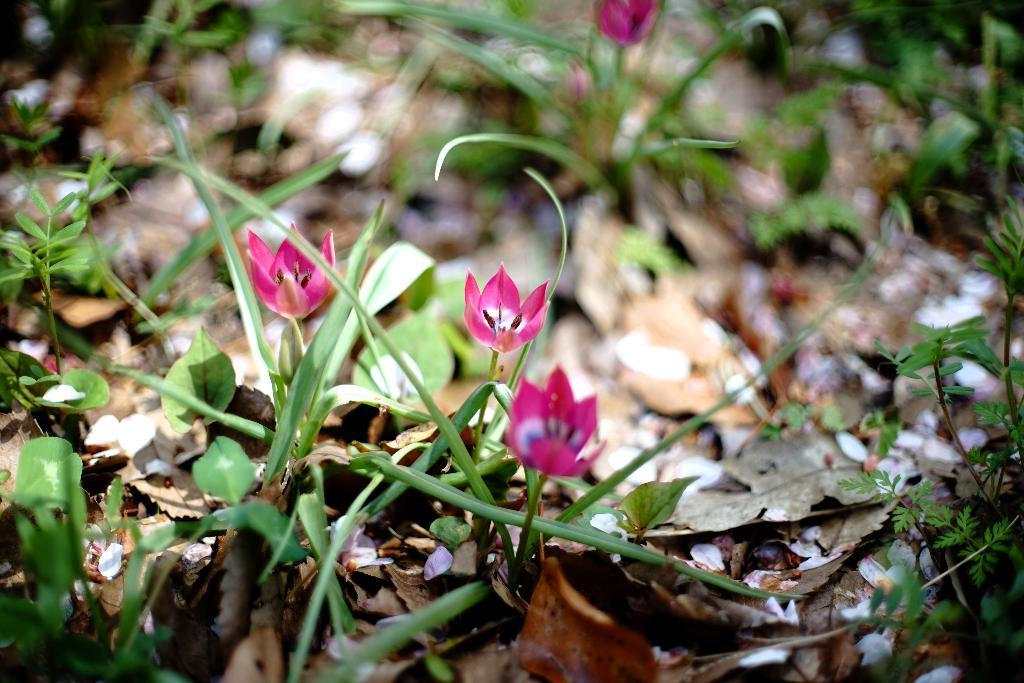What type of plants can be seen in the image? There are plants with flowers in the image. What can be observed on the ground in the image? There are dried leaves on the land in the image. What type of sheet is covering the lettuce in the image? There is no sheet or lettuce present in the image; it features plants with flowers and dried leaves on the ground. 